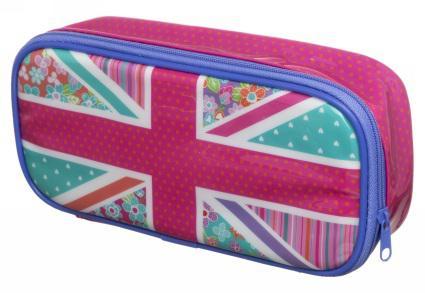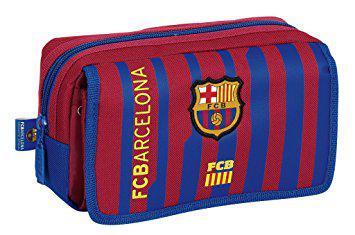The first image is the image on the left, the second image is the image on the right. For the images displayed, is the sentence "The pencil case to the left contains a lot of the color pink." factually correct? Answer yes or no. Yes. The first image is the image on the left, the second image is the image on the right. Examine the images to the left and right. Is the description "No case is displayed open, and at least one rectangular case with rounded corners and hot pink color scheme is displayed standing on its long side." accurate? Answer yes or no. Yes. 